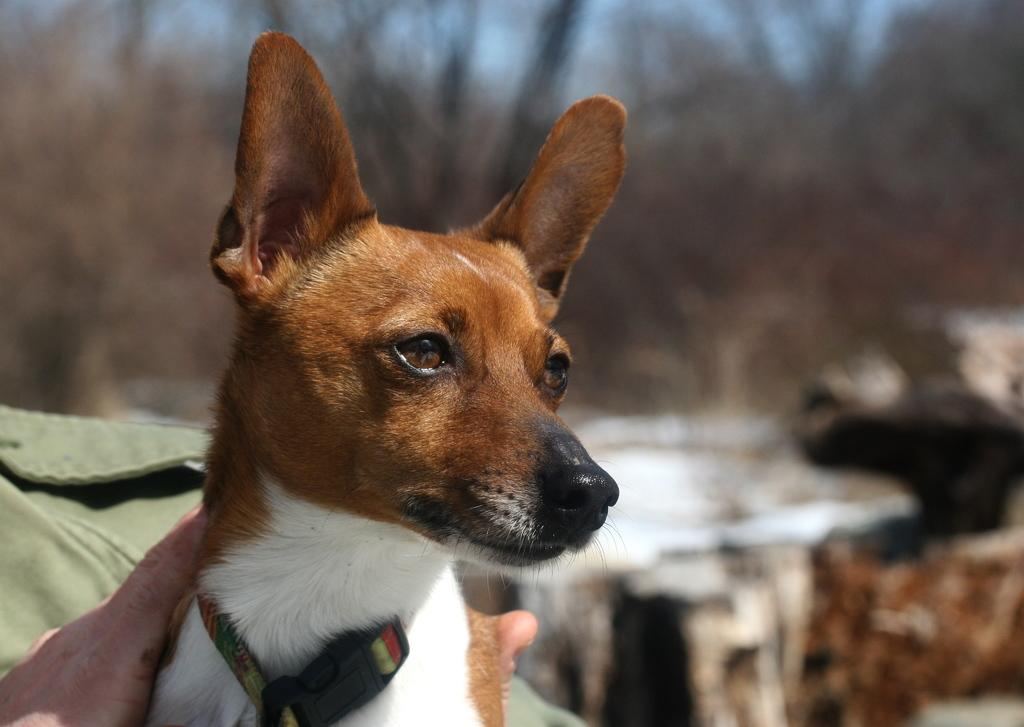Who is the main subject in the foreground of the picture? There is a man in the foreground of the picture. What is the man holding in the picture? The man is holding a dog. What can be seen in the background of the picture? There are trees and the sky visible in the background of the picture. What type of tooth is visible in the picture? There is no tooth visible in the picture; it features a man holding a dog in the foreground and trees and the sky in the background. 